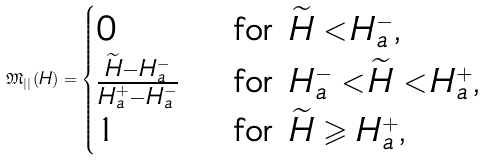<formula> <loc_0><loc_0><loc_500><loc_500>\mathfrak { M } _ { | | } ( H ) = \begin{cases} 0 & \text { for $\widetilde{H} < H_{a}^{-}$,} \\ \frac { \widetilde { H } - H _ { a } ^ { - } } { H _ { a } ^ { + } - H _ { a } ^ { - } } & \text { for $H_{a}^{-} < \widetilde{H} < H_{a}^{+}$,} \\ 1 & \text { for $\widetilde{H} \geqslant H_{a}^{+}$,} \end{cases}</formula> 